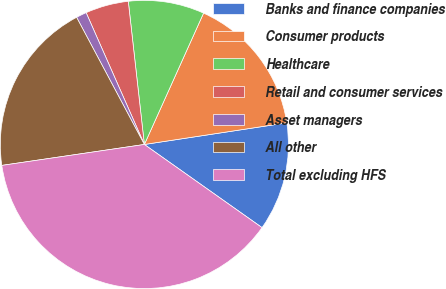Convert chart. <chart><loc_0><loc_0><loc_500><loc_500><pie_chart><fcel>Banks and finance companies<fcel>Consumer products<fcel>Healthcare<fcel>Retail and consumer services<fcel>Asset managers<fcel>All other<fcel>Total excluding HFS<nl><fcel>12.19%<fcel>15.86%<fcel>8.52%<fcel>4.84%<fcel>1.17%<fcel>19.53%<fcel>37.89%<nl></chart> 